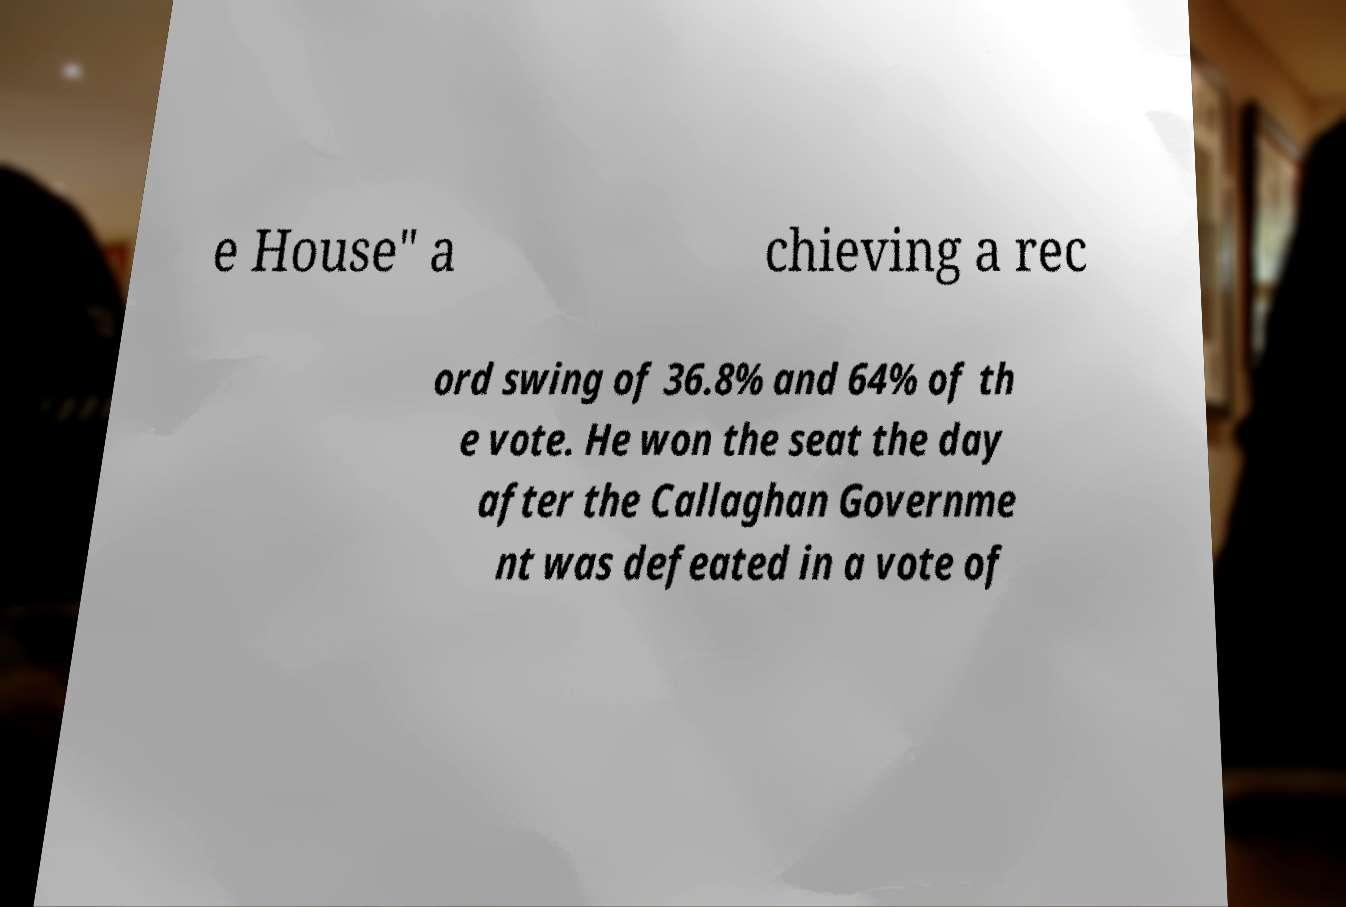Please read and relay the text visible in this image. What does it say? e House" a chieving a rec ord swing of 36.8% and 64% of th e vote. He won the seat the day after the Callaghan Governme nt was defeated in a vote of 